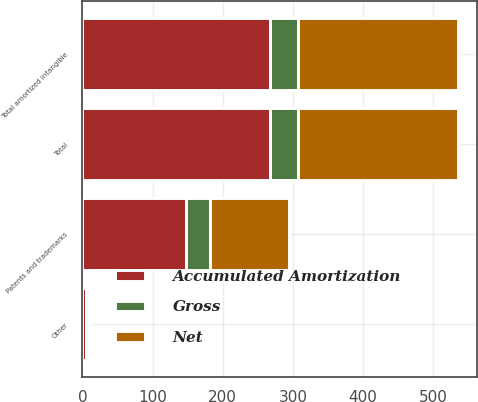<chart> <loc_0><loc_0><loc_500><loc_500><stacked_bar_chart><ecel><fcel>Patents and trademarks<fcel>Other<fcel>Total amortized intangible<fcel>Total<nl><fcel>Accumulated Amortization<fcel>147<fcel>5<fcel>268<fcel>268<nl><fcel>Net<fcel>112<fcel>1<fcel>229<fcel>229<nl><fcel>Gross<fcel>35<fcel>4<fcel>39<fcel>39<nl></chart> 